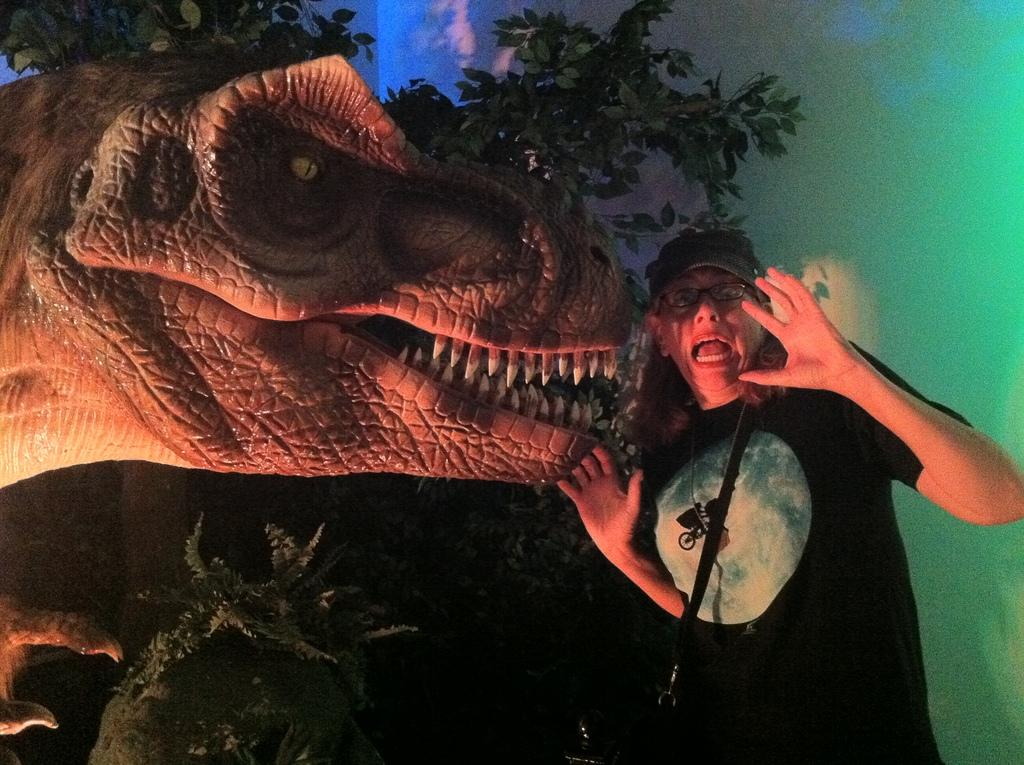Who or what is the main subject in the image? There is a person in the image. What is the person wearing? The person is wearing a black T-shirt. What can be seen in the background of the image? There is a wall and plants in the background of the image. What is located on the left side of the image? There is a dinosaur on the left side of the image. What type of grain is being harvested by the fireman in the image? There is no fireman or grain present in the image; it features a person wearing a black T-shirt and a dinosaur on the left side. 